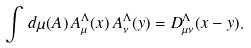Convert formula to latex. <formula><loc_0><loc_0><loc_500><loc_500>\int \, d \mu ( A ) \, A _ { \mu } ^ { \Lambda } ( x ) \, A _ { \nu } ^ { \Lambda } ( y ) = D _ { \mu \nu } ^ { \Lambda } ( x - y ) .</formula> 